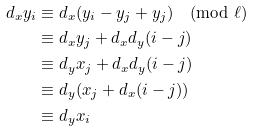Convert formula to latex. <formula><loc_0><loc_0><loc_500><loc_500>d _ { x } y _ { i } & \equiv d _ { x } ( y _ { i } - y _ { j } + y _ { j } ) \pmod { \ell } \\ & \equiv d _ { x } y _ { j } + d _ { x } d _ { y } ( i - j ) \\ & \equiv d _ { y } x _ { j } + d _ { x } d _ { y } ( i - j ) \\ & \equiv d _ { y } ( x _ { j } + d _ { x } ( i - j ) ) \\ & \equiv d _ { y } x _ { i }</formula> 